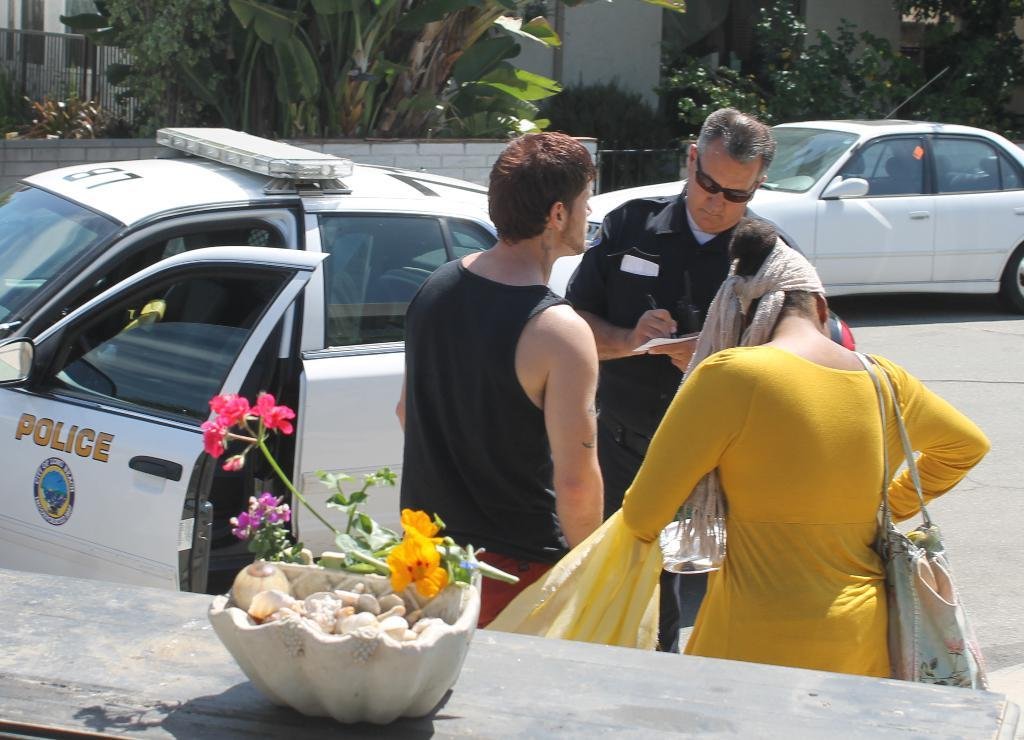<image>
Share a concise interpretation of the image provided. A police officer is writing a ticket to a man and woman and his car says Police on the door. 